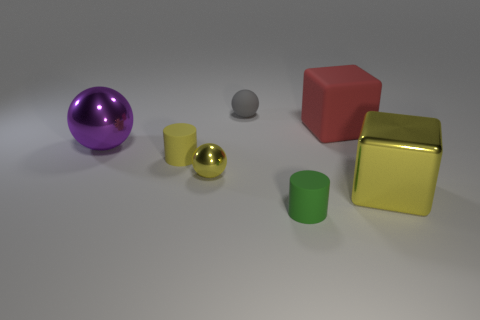How many objects are there in total within the image, and can you describe their shapes? There are six objects in the image. Starting from the left, there's a purple reflective sphere, a smaller grey matte cylinder, a yellow reflective sphere, a small green matte cylinder, a large red cube, and a large yellow cube with a metallic sheen. 